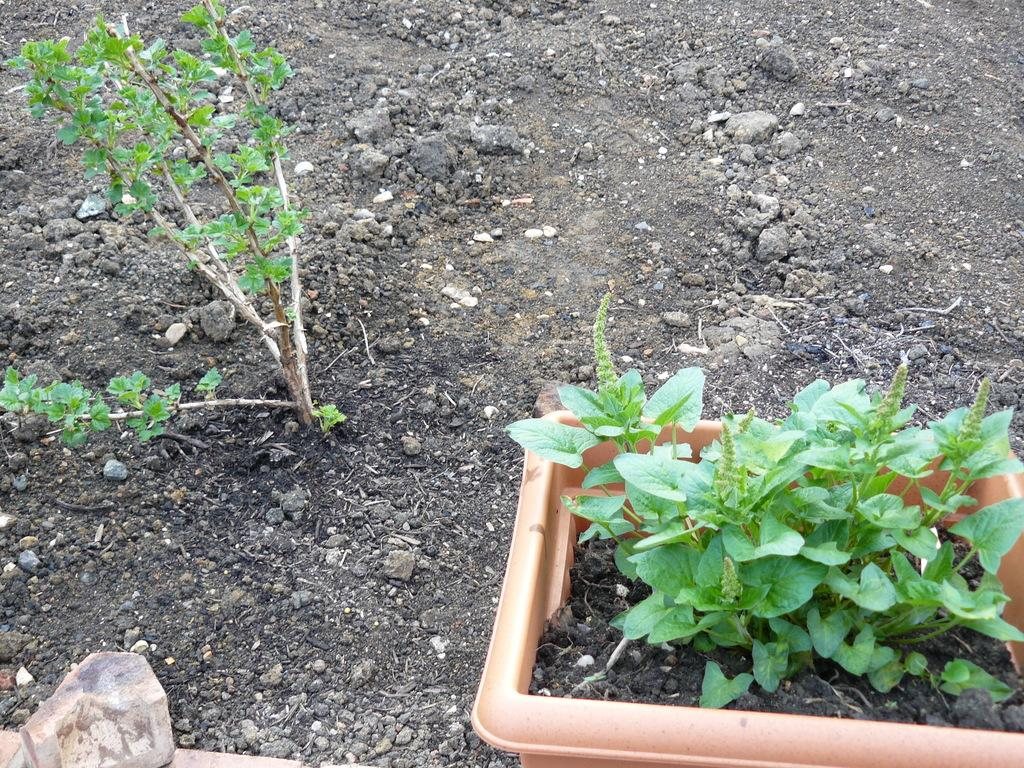What type of object is on the ground in the image? There is a plant on the ground in the image. Can you describe another object on the ground? There is a potted plant on the ground in the image. What is the third object on the ground? There is a stone on the ground in the image. How many balls are visible in the image? There are no balls present in the image. Can you describe the temperature of the plant in the image? The temperature of the plant cannot be determined from the image alone. 